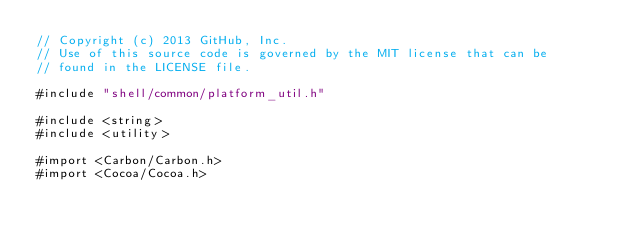Convert code to text. <code><loc_0><loc_0><loc_500><loc_500><_ObjectiveC_>// Copyright (c) 2013 GitHub, Inc.
// Use of this source code is governed by the MIT license that can be
// found in the LICENSE file.

#include "shell/common/platform_util.h"

#include <string>
#include <utility>

#import <Carbon/Carbon.h>
#import <Cocoa/Cocoa.h></code> 